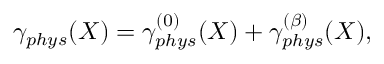<formula> <loc_0><loc_0><loc_500><loc_500>\gamma _ { p h y s } ( X ) = \gamma _ { p h y s } ^ { ( 0 ) } ( X ) + \gamma _ { p h y s } ^ { ( \beta ) } ( X ) ,</formula> 